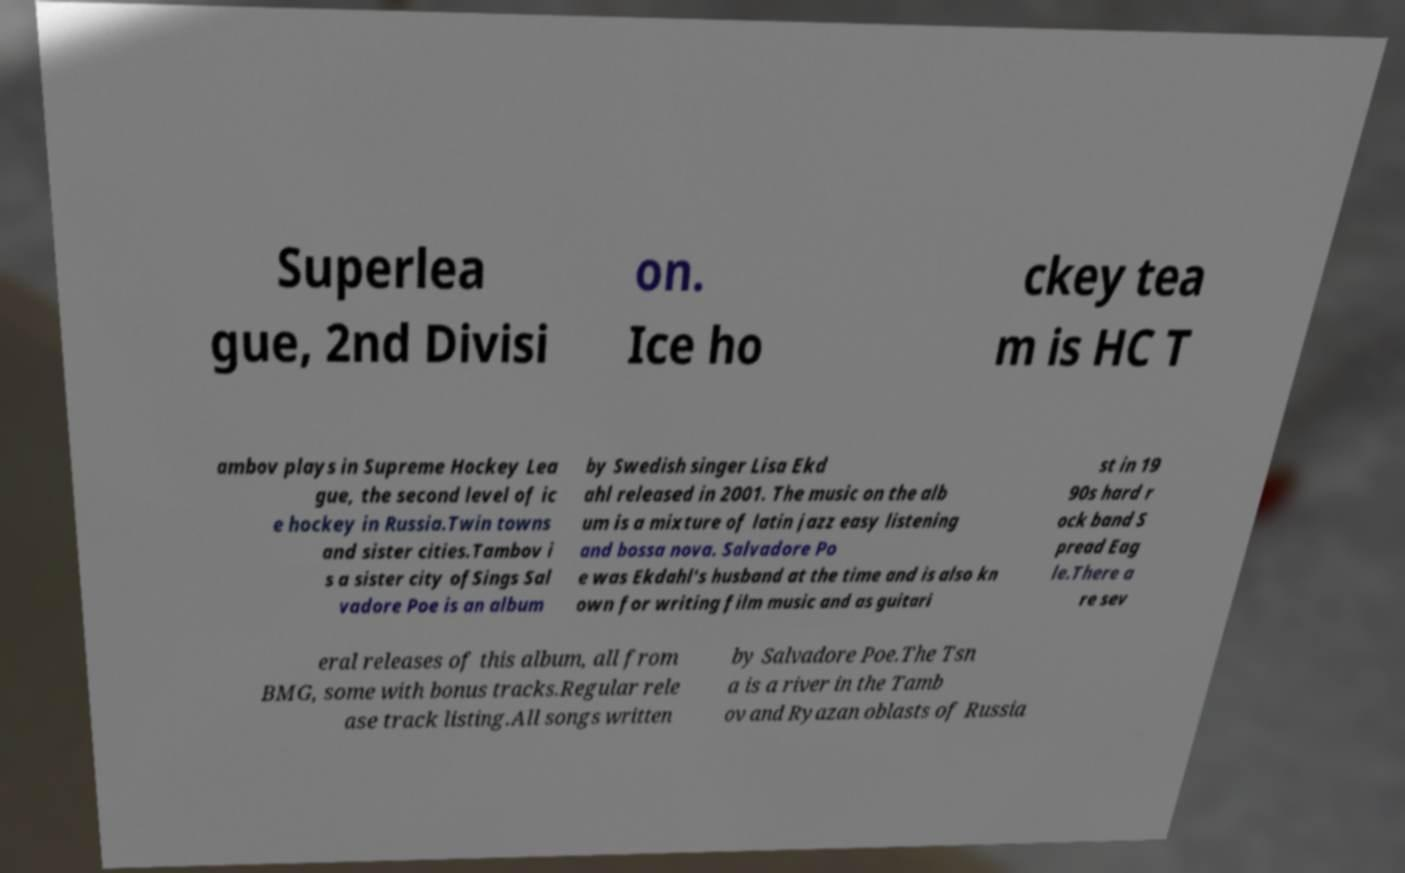I need the written content from this picture converted into text. Can you do that? Superlea gue, 2nd Divisi on. Ice ho ckey tea m is HC T ambov plays in Supreme Hockey Lea gue, the second level of ic e hockey in Russia.Twin towns and sister cities.Tambov i s a sister city ofSings Sal vadore Poe is an album by Swedish singer Lisa Ekd ahl released in 2001. The music on the alb um is a mixture of latin jazz easy listening and bossa nova. Salvadore Po e was Ekdahl's husband at the time and is also kn own for writing film music and as guitari st in 19 90s hard r ock band S pread Eag le.There a re sev eral releases of this album, all from BMG, some with bonus tracks.Regular rele ase track listing.All songs written by Salvadore Poe.The Tsn a is a river in the Tamb ov and Ryazan oblasts of Russia 